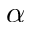<formula> <loc_0><loc_0><loc_500><loc_500>\alpha</formula> 